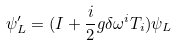Convert formula to latex. <formula><loc_0><loc_0><loc_500><loc_500>\psi ^ { \prime } _ { L } = ( I + \frac { i } { 2 } g \delta \omega ^ { i } T _ { i } ) \psi _ { L }</formula> 